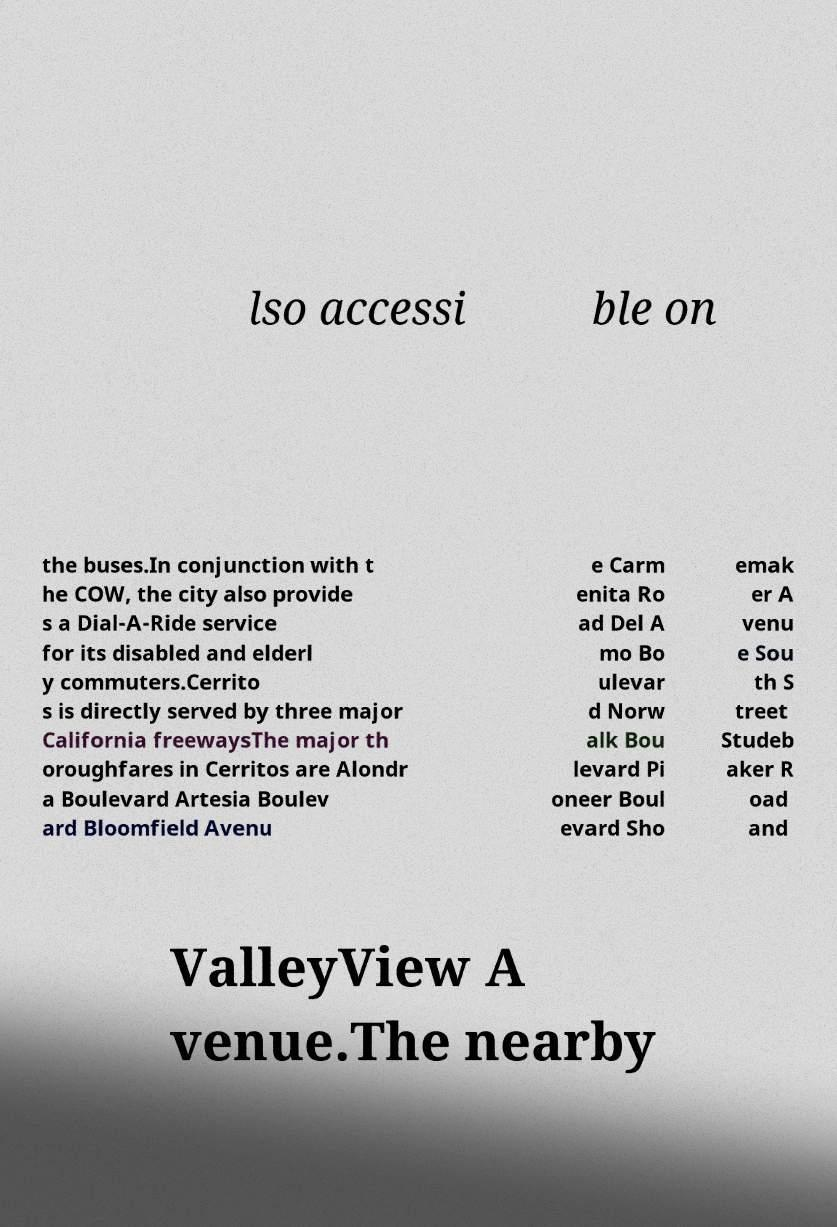Can you read and provide the text displayed in the image?This photo seems to have some interesting text. Can you extract and type it out for me? lso accessi ble on the buses.In conjunction with t he COW, the city also provide s a Dial-A-Ride service for its disabled and elderl y commuters.Cerrito s is directly served by three major California freewaysThe major th oroughfares in Cerritos are Alondr a Boulevard Artesia Boulev ard Bloomfield Avenu e Carm enita Ro ad Del A mo Bo ulevar d Norw alk Bou levard Pi oneer Boul evard Sho emak er A venu e Sou th S treet Studeb aker R oad and ValleyView A venue.The nearby 